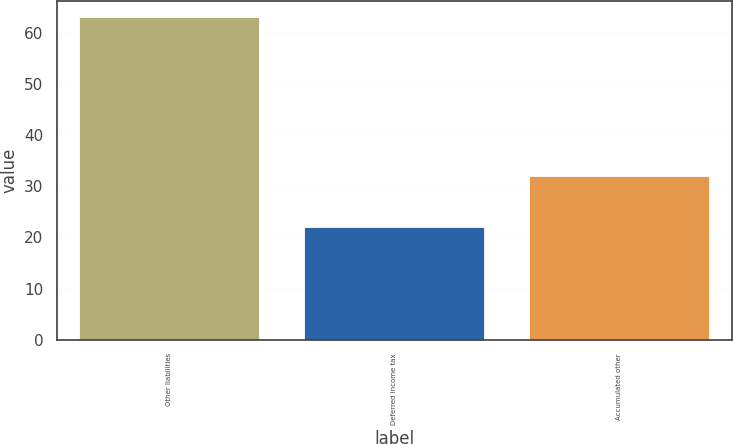Convert chart. <chart><loc_0><loc_0><loc_500><loc_500><bar_chart><fcel>Other liabilities<fcel>Deferred income tax<fcel>Accumulated other<nl><fcel>63<fcel>22<fcel>32<nl></chart> 